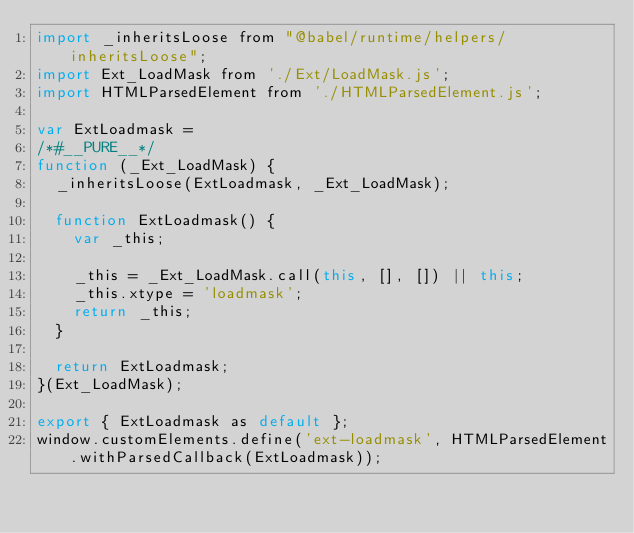Convert code to text. <code><loc_0><loc_0><loc_500><loc_500><_JavaScript_>import _inheritsLoose from "@babel/runtime/helpers/inheritsLoose";
import Ext_LoadMask from './Ext/LoadMask.js';
import HTMLParsedElement from './HTMLParsedElement.js';

var ExtLoadmask =
/*#__PURE__*/
function (_Ext_LoadMask) {
  _inheritsLoose(ExtLoadmask, _Ext_LoadMask);

  function ExtLoadmask() {
    var _this;

    _this = _Ext_LoadMask.call(this, [], []) || this;
    _this.xtype = 'loadmask';
    return _this;
  }

  return ExtLoadmask;
}(Ext_LoadMask);

export { ExtLoadmask as default };
window.customElements.define('ext-loadmask', HTMLParsedElement.withParsedCallback(ExtLoadmask));</code> 